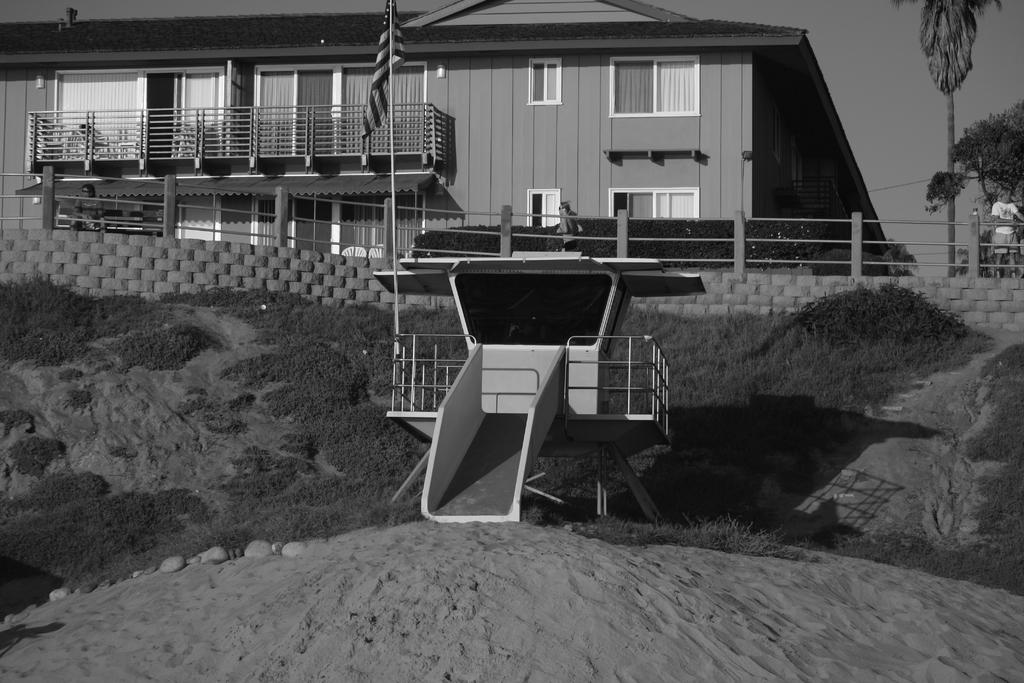What type of picture is in the image? The image contains a black and white picture of a building. What architectural features can be seen on the building? The building has windows. What additional element is present in the image? There is a flag in the image. What type of natural elements are visible in the image? Stones, grass, and trees are present in the image. What part of the natural environment is visible in the image? The sky is visible in the image. How many wishes can be granted by the zipper in the image? There is no zipper present in the image, so it is not possible to grant any wishes. 